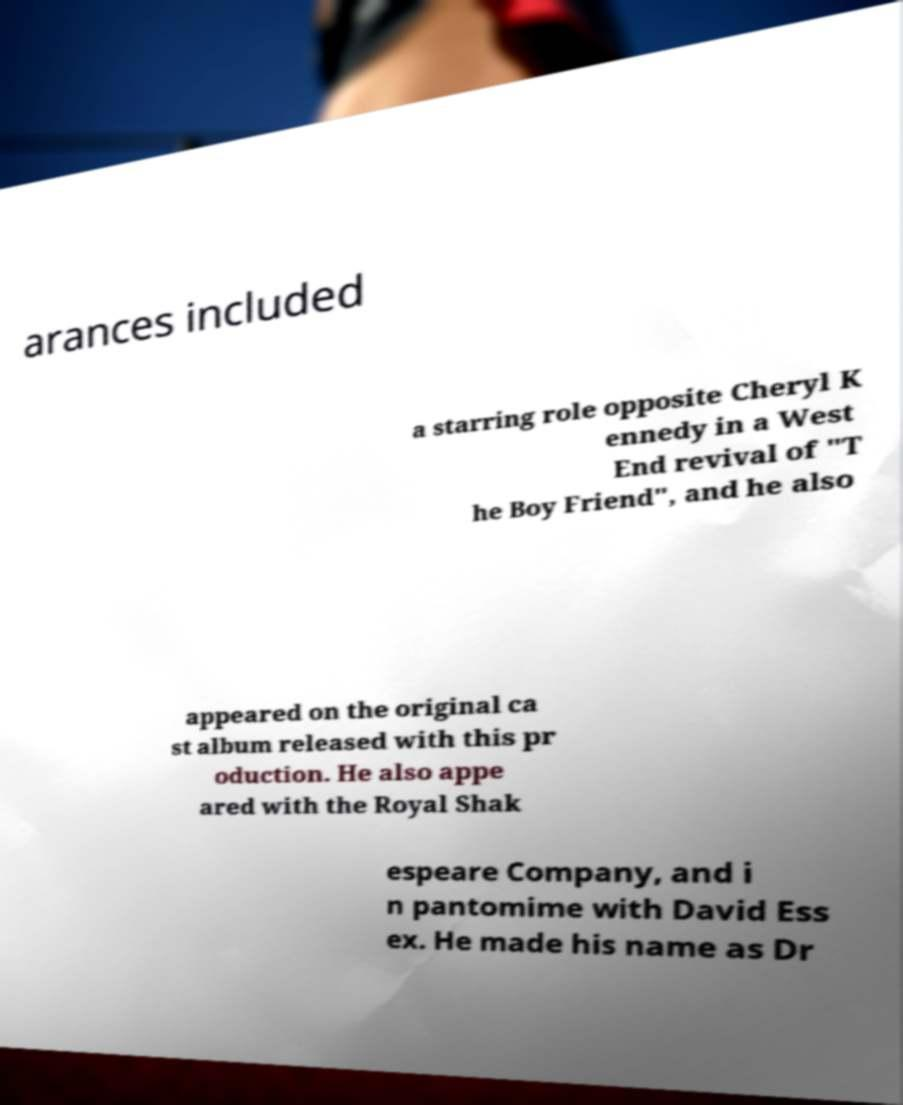There's text embedded in this image that I need extracted. Can you transcribe it verbatim? arances included a starring role opposite Cheryl K ennedy in a West End revival of "T he Boy Friend", and he also appeared on the original ca st album released with this pr oduction. He also appe ared with the Royal Shak espeare Company, and i n pantomime with David Ess ex. He made his name as Dr 